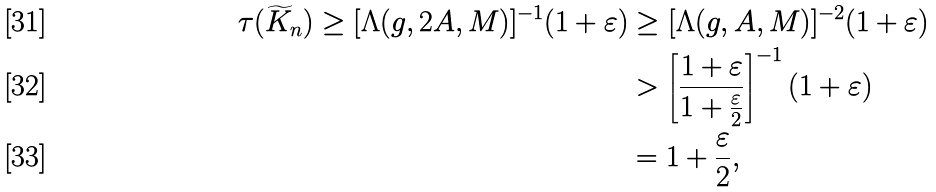Convert formula to latex. <formula><loc_0><loc_0><loc_500><loc_500>\tau ( \widetilde { K } _ { n } ) \geq [ \Lambda ( g , 2 A , M ) ] ^ { - 1 } ( 1 + \varepsilon ) & \geq [ \Lambda ( g , A , M ) ] ^ { - 2 } ( 1 + \varepsilon ) \\ & > \left [ \frac { 1 + \varepsilon } { 1 + \frac { \varepsilon } { 2 } } \right ] ^ { - 1 } ( 1 + \varepsilon ) \\ & = 1 + \frac { \varepsilon } { 2 } ,</formula> 